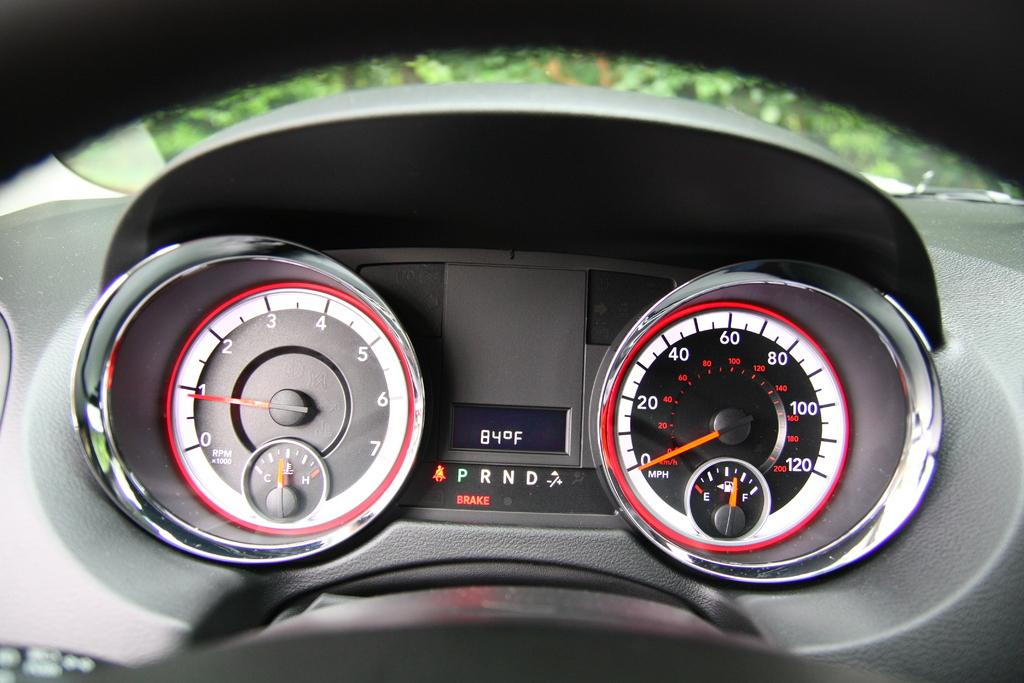How many meter indicators are visible in the image? There are two meter indicators in the image. What are the meter indicators attached to? The meter indicators are attached to a vehicle. What additional information is displayed between the meter indicators? There is a screen displaying the temperature between the meter indicators. What type of milk is being traded on the screen between the meter indicators? There is no mention of milk or trade in the image; the screen displays the temperature. 